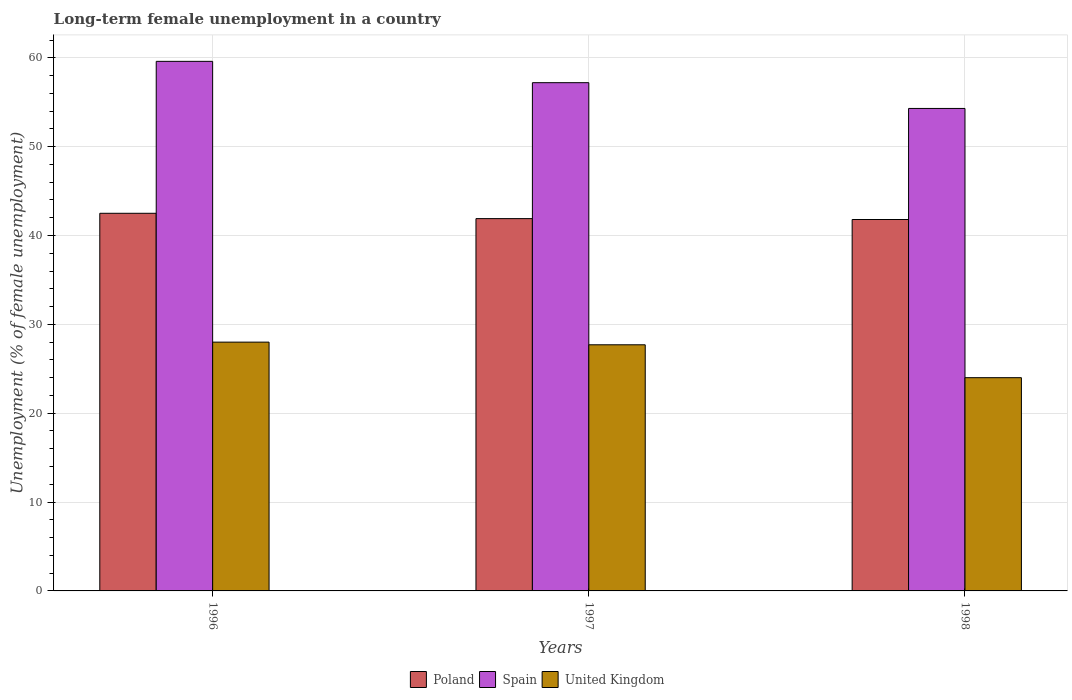How many groups of bars are there?
Your answer should be very brief. 3. Are the number of bars per tick equal to the number of legend labels?
Keep it short and to the point. Yes. Are the number of bars on each tick of the X-axis equal?
Keep it short and to the point. Yes. How many bars are there on the 1st tick from the right?
Offer a terse response. 3. In how many cases, is the number of bars for a given year not equal to the number of legend labels?
Offer a very short reply. 0. What is the percentage of long-term unemployed female population in Spain in 1997?
Provide a succinct answer. 57.2. Across all years, what is the minimum percentage of long-term unemployed female population in Poland?
Give a very brief answer. 41.8. In which year was the percentage of long-term unemployed female population in Spain maximum?
Your answer should be compact. 1996. In which year was the percentage of long-term unemployed female population in Poland minimum?
Your answer should be compact. 1998. What is the total percentage of long-term unemployed female population in United Kingdom in the graph?
Your answer should be compact. 79.7. What is the difference between the percentage of long-term unemployed female population in Poland in 1996 and that in 1998?
Offer a terse response. 0.7. What is the difference between the percentage of long-term unemployed female population in Poland in 1998 and the percentage of long-term unemployed female population in Spain in 1996?
Give a very brief answer. -17.8. What is the average percentage of long-term unemployed female population in United Kingdom per year?
Your answer should be compact. 26.57. In the year 1997, what is the difference between the percentage of long-term unemployed female population in Poland and percentage of long-term unemployed female population in United Kingdom?
Provide a succinct answer. 14.2. In how many years, is the percentage of long-term unemployed female population in Poland greater than 60 %?
Provide a succinct answer. 0. What is the ratio of the percentage of long-term unemployed female population in Poland in 1996 to that in 1997?
Give a very brief answer. 1.01. What is the difference between the highest and the second highest percentage of long-term unemployed female population in United Kingdom?
Give a very brief answer. 0.3. What is the difference between the highest and the lowest percentage of long-term unemployed female population in United Kingdom?
Ensure brevity in your answer.  4. Is the sum of the percentage of long-term unemployed female population in Poland in 1996 and 1998 greater than the maximum percentage of long-term unemployed female population in Spain across all years?
Ensure brevity in your answer.  Yes. Is it the case that in every year, the sum of the percentage of long-term unemployed female population in Poland and percentage of long-term unemployed female population in Spain is greater than the percentage of long-term unemployed female population in United Kingdom?
Offer a very short reply. Yes. What is the difference between two consecutive major ticks on the Y-axis?
Make the answer very short. 10. Where does the legend appear in the graph?
Your response must be concise. Bottom center. How are the legend labels stacked?
Offer a very short reply. Horizontal. What is the title of the graph?
Offer a terse response. Long-term female unemployment in a country. What is the label or title of the Y-axis?
Provide a succinct answer. Unemployment (% of female unemployment). What is the Unemployment (% of female unemployment) of Poland in 1996?
Keep it short and to the point. 42.5. What is the Unemployment (% of female unemployment) of Spain in 1996?
Provide a short and direct response. 59.6. What is the Unemployment (% of female unemployment) in United Kingdom in 1996?
Keep it short and to the point. 28. What is the Unemployment (% of female unemployment) of Poland in 1997?
Make the answer very short. 41.9. What is the Unemployment (% of female unemployment) of Spain in 1997?
Your answer should be compact. 57.2. What is the Unemployment (% of female unemployment) of United Kingdom in 1997?
Offer a very short reply. 27.7. What is the Unemployment (% of female unemployment) of Poland in 1998?
Provide a short and direct response. 41.8. What is the Unemployment (% of female unemployment) of Spain in 1998?
Offer a very short reply. 54.3. Across all years, what is the maximum Unemployment (% of female unemployment) of Poland?
Offer a terse response. 42.5. Across all years, what is the maximum Unemployment (% of female unemployment) in Spain?
Ensure brevity in your answer.  59.6. Across all years, what is the minimum Unemployment (% of female unemployment) in Poland?
Give a very brief answer. 41.8. Across all years, what is the minimum Unemployment (% of female unemployment) of Spain?
Keep it short and to the point. 54.3. What is the total Unemployment (% of female unemployment) of Poland in the graph?
Keep it short and to the point. 126.2. What is the total Unemployment (% of female unemployment) of Spain in the graph?
Offer a very short reply. 171.1. What is the total Unemployment (% of female unemployment) of United Kingdom in the graph?
Your response must be concise. 79.7. What is the difference between the Unemployment (% of female unemployment) in Spain in 1996 and that in 1997?
Your response must be concise. 2.4. What is the difference between the Unemployment (% of female unemployment) in Spain in 1996 and that in 1998?
Your response must be concise. 5.3. What is the difference between the Unemployment (% of female unemployment) in United Kingdom in 1996 and that in 1998?
Your answer should be very brief. 4. What is the difference between the Unemployment (% of female unemployment) of Poland in 1997 and that in 1998?
Offer a very short reply. 0.1. What is the difference between the Unemployment (% of female unemployment) of United Kingdom in 1997 and that in 1998?
Your response must be concise. 3.7. What is the difference between the Unemployment (% of female unemployment) of Poland in 1996 and the Unemployment (% of female unemployment) of Spain in 1997?
Ensure brevity in your answer.  -14.7. What is the difference between the Unemployment (% of female unemployment) of Poland in 1996 and the Unemployment (% of female unemployment) of United Kingdom in 1997?
Keep it short and to the point. 14.8. What is the difference between the Unemployment (% of female unemployment) in Spain in 1996 and the Unemployment (% of female unemployment) in United Kingdom in 1997?
Your answer should be compact. 31.9. What is the difference between the Unemployment (% of female unemployment) in Poland in 1996 and the Unemployment (% of female unemployment) in United Kingdom in 1998?
Your answer should be compact. 18.5. What is the difference between the Unemployment (% of female unemployment) of Spain in 1996 and the Unemployment (% of female unemployment) of United Kingdom in 1998?
Your answer should be compact. 35.6. What is the difference between the Unemployment (% of female unemployment) in Poland in 1997 and the Unemployment (% of female unemployment) in Spain in 1998?
Your response must be concise. -12.4. What is the difference between the Unemployment (% of female unemployment) in Poland in 1997 and the Unemployment (% of female unemployment) in United Kingdom in 1998?
Offer a very short reply. 17.9. What is the difference between the Unemployment (% of female unemployment) in Spain in 1997 and the Unemployment (% of female unemployment) in United Kingdom in 1998?
Your response must be concise. 33.2. What is the average Unemployment (% of female unemployment) in Poland per year?
Provide a succinct answer. 42.07. What is the average Unemployment (% of female unemployment) of Spain per year?
Provide a short and direct response. 57.03. What is the average Unemployment (% of female unemployment) in United Kingdom per year?
Offer a very short reply. 26.57. In the year 1996, what is the difference between the Unemployment (% of female unemployment) of Poland and Unemployment (% of female unemployment) of Spain?
Provide a short and direct response. -17.1. In the year 1996, what is the difference between the Unemployment (% of female unemployment) of Spain and Unemployment (% of female unemployment) of United Kingdom?
Make the answer very short. 31.6. In the year 1997, what is the difference between the Unemployment (% of female unemployment) of Poland and Unemployment (% of female unemployment) of Spain?
Keep it short and to the point. -15.3. In the year 1997, what is the difference between the Unemployment (% of female unemployment) in Poland and Unemployment (% of female unemployment) in United Kingdom?
Your response must be concise. 14.2. In the year 1997, what is the difference between the Unemployment (% of female unemployment) in Spain and Unemployment (% of female unemployment) in United Kingdom?
Provide a succinct answer. 29.5. In the year 1998, what is the difference between the Unemployment (% of female unemployment) of Poland and Unemployment (% of female unemployment) of United Kingdom?
Your answer should be very brief. 17.8. In the year 1998, what is the difference between the Unemployment (% of female unemployment) in Spain and Unemployment (% of female unemployment) in United Kingdom?
Offer a very short reply. 30.3. What is the ratio of the Unemployment (% of female unemployment) in Poland in 1996 to that in 1997?
Ensure brevity in your answer.  1.01. What is the ratio of the Unemployment (% of female unemployment) of Spain in 1996 to that in 1997?
Make the answer very short. 1.04. What is the ratio of the Unemployment (% of female unemployment) of United Kingdom in 1996 to that in 1997?
Provide a short and direct response. 1.01. What is the ratio of the Unemployment (% of female unemployment) of Poland in 1996 to that in 1998?
Provide a short and direct response. 1.02. What is the ratio of the Unemployment (% of female unemployment) of Spain in 1996 to that in 1998?
Keep it short and to the point. 1.1. What is the ratio of the Unemployment (% of female unemployment) of Poland in 1997 to that in 1998?
Your response must be concise. 1. What is the ratio of the Unemployment (% of female unemployment) in Spain in 1997 to that in 1998?
Give a very brief answer. 1.05. What is the ratio of the Unemployment (% of female unemployment) in United Kingdom in 1997 to that in 1998?
Offer a terse response. 1.15. What is the difference between the highest and the lowest Unemployment (% of female unemployment) of United Kingdom?
Your answer should be very brief. 4. 